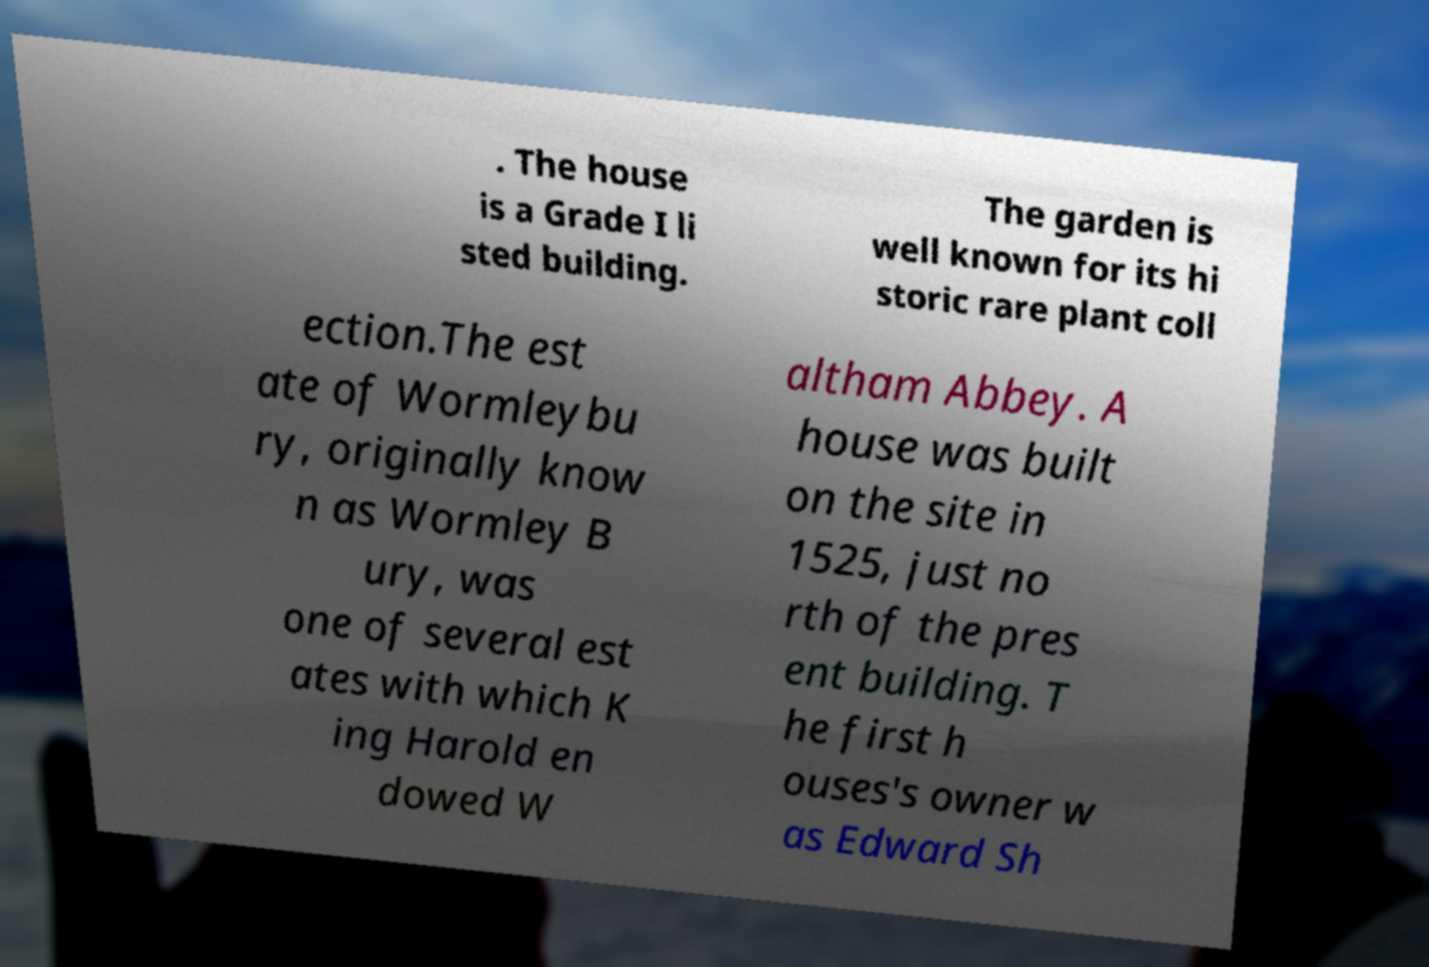Can you read and provide the text displayed in the image?This photo seems to have some interesting text. Can you extract and type it out for me? . The house is a Grade I li sted building. The garden is well known for its hi storic rare plant coll ection.The est ate of Wormleybu ry, originally know n as Wormley B ury, was one of several est ates with which K ing Harold en dowed W altham Abbey. A house was built on the site in 1525, just no rth of the pres ent building. T he first h ouses's owner w as Edward Sh 